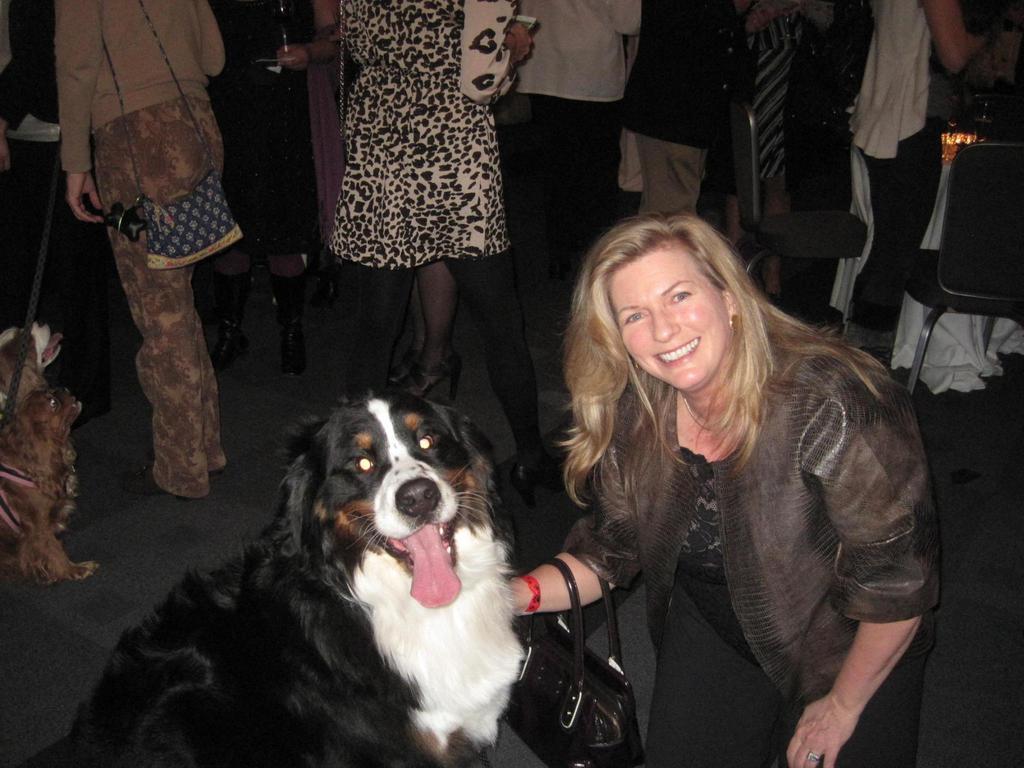Describe this image in one or two sentences. In this image I can see a woman who is smiling and she is carrying a handbag and she is touching the dog with her hand. In the background I can see lot of people standing and 2 dogs over here. 